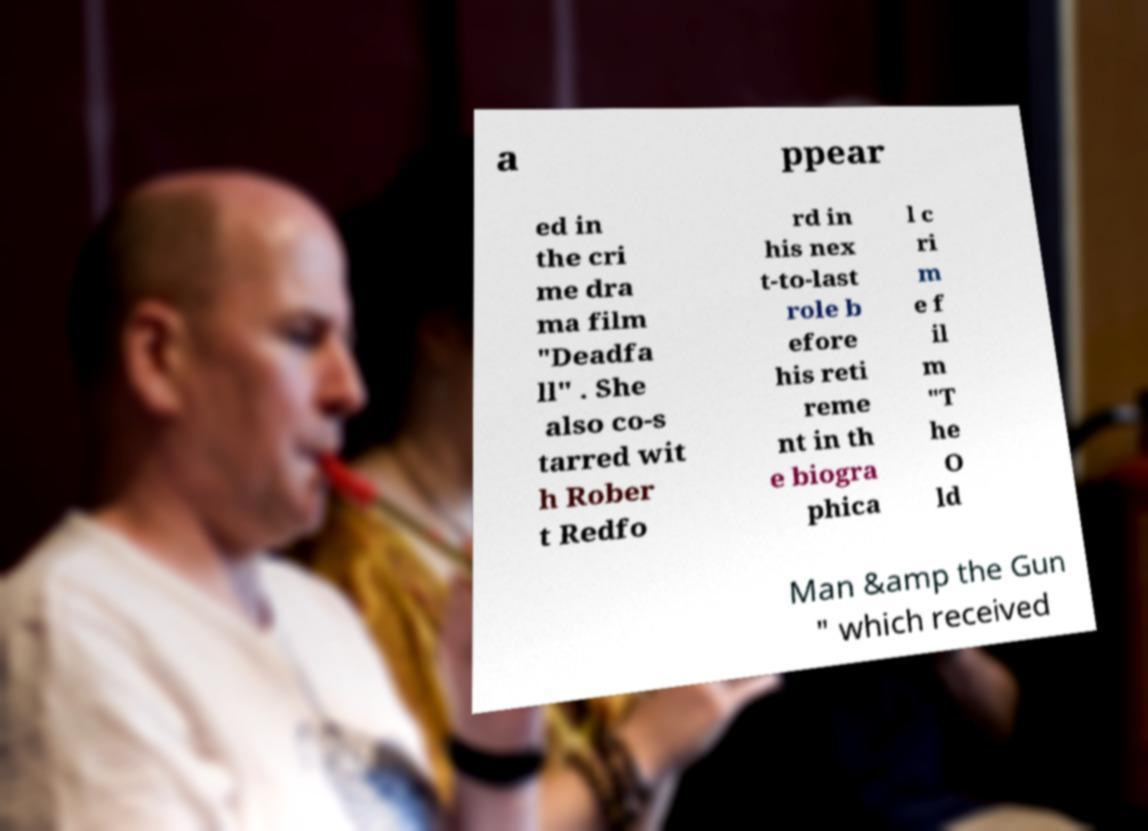There's text embedded in this image that I need extracted. Can you transcribe it verbatim? a ppear ed in the cri me dra ma film "Deadfa ll" . She also co-s tarred wit h Rober t Redfo rd in his nex t-to-last role b efore his reti reme nt in th e biogra phica l c ri m e f il m "T he O ld Man &amp the Gun " which received 